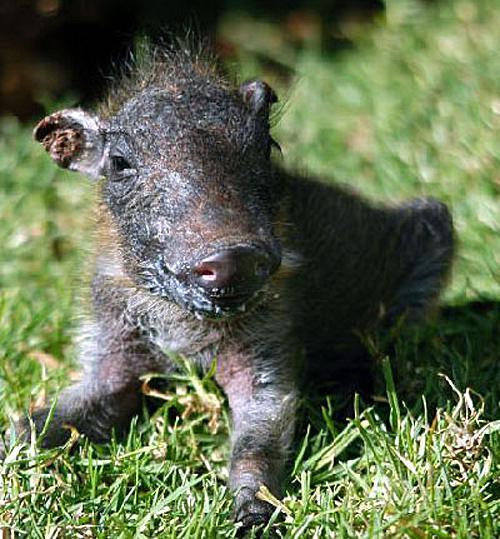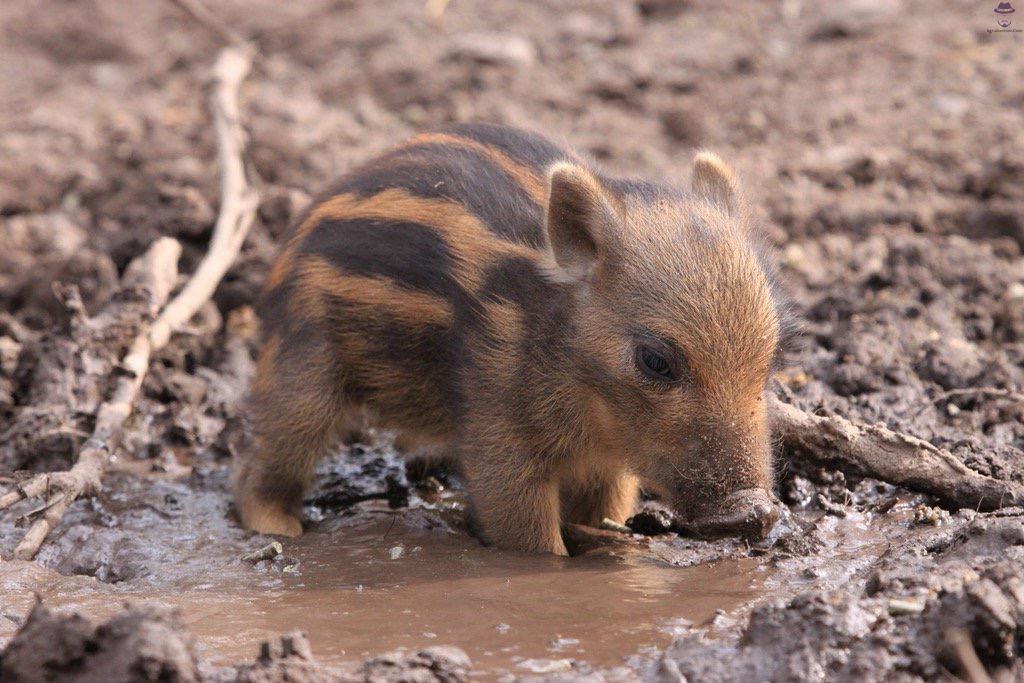The first image is the image on the left, the second image is the image on the right. Assess this claim about the two images: "There are two hogs facing each other in one of the images.". Correct or not? Answer yes or no. No. The first image is the image on the left, the second image is the image on the right. Assess this claim about the two images: "The lefthand image contains one young warthog, and the righthand image contains two young warthogs.". Correct or not? Answer yes or no. No. 